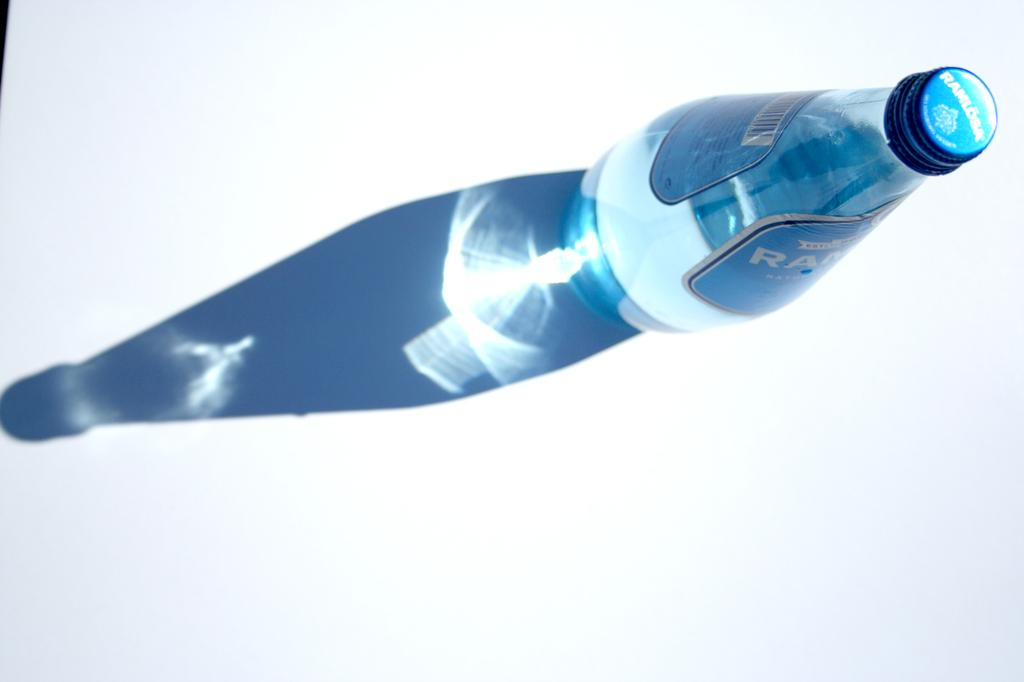What object is visible in the image? There is a bottle in the image. Where is the bottle located? The bottle is placed on a table. Can you describe any additional features related to the bottle in the image? There is a shadow of the bottle in the image. What type of bubble can be seen in the image? There is no bubble present in the image. 